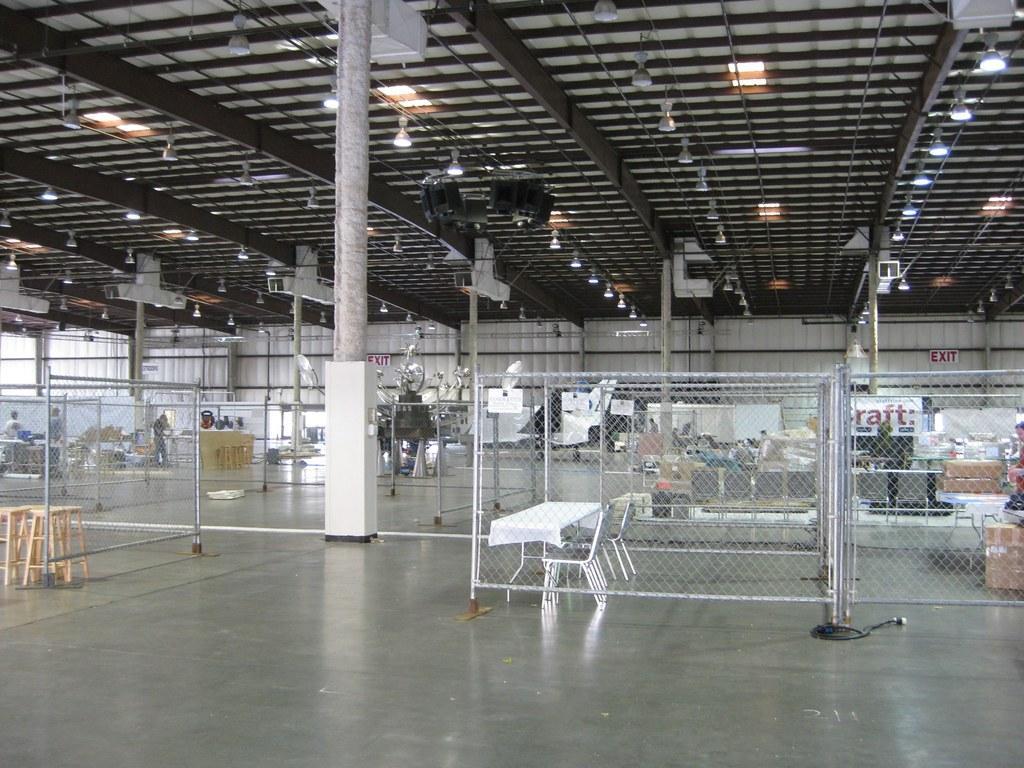In one or two sentences, can you explain what this image depicts? In this image we can see an inner view of a room containing some benches, tables, chairs, cardboard boxes and some poles. On the left side we can see some people standing. We can also see a roof with some ceiling lights. 